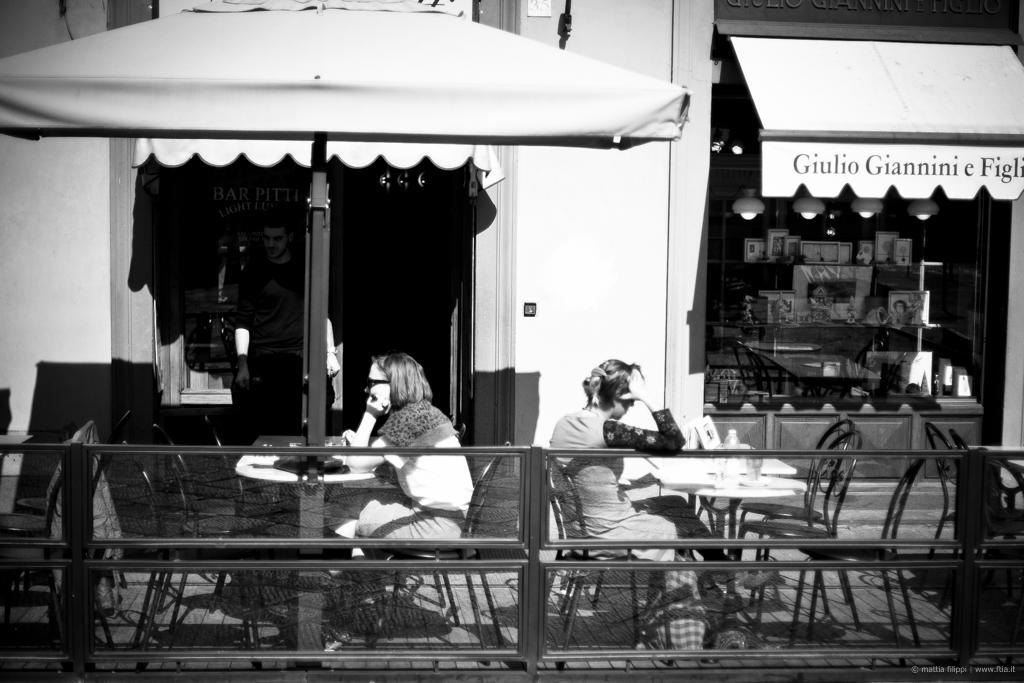How many people are sitting in the image? There are two people sitting on chairs in the image. What can be seen in the background of the image? There are objects visible in the background of the image. What type of structure is present in the image? There is a fence in the image. What might be used for providing shade in the image? There are sun shades in the image. What type of furniture is present in the image? There are tables in the image. How many children are learning to play the nerve in the image? There are no children or nerves present in the image. 